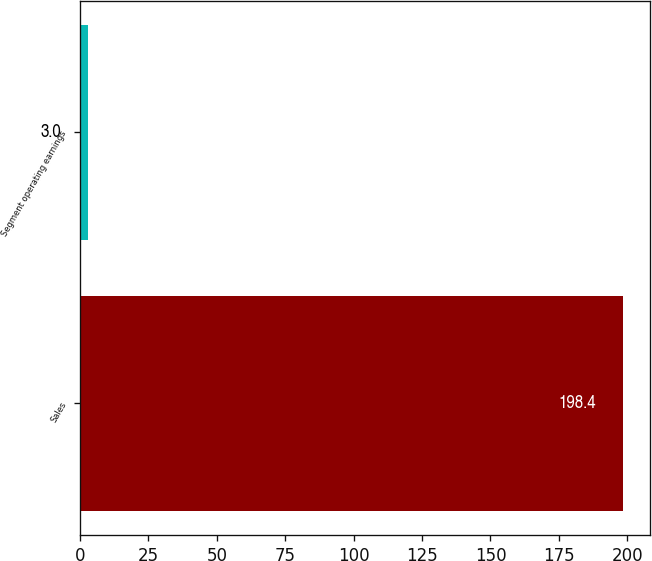<chart> <loc_0><loc_0><loc_500><loc_500><bar_chart><fcel>Sales<fcel>Segment operating earnings<nl><fcel>198.4<fcel>3<nl></chart> 